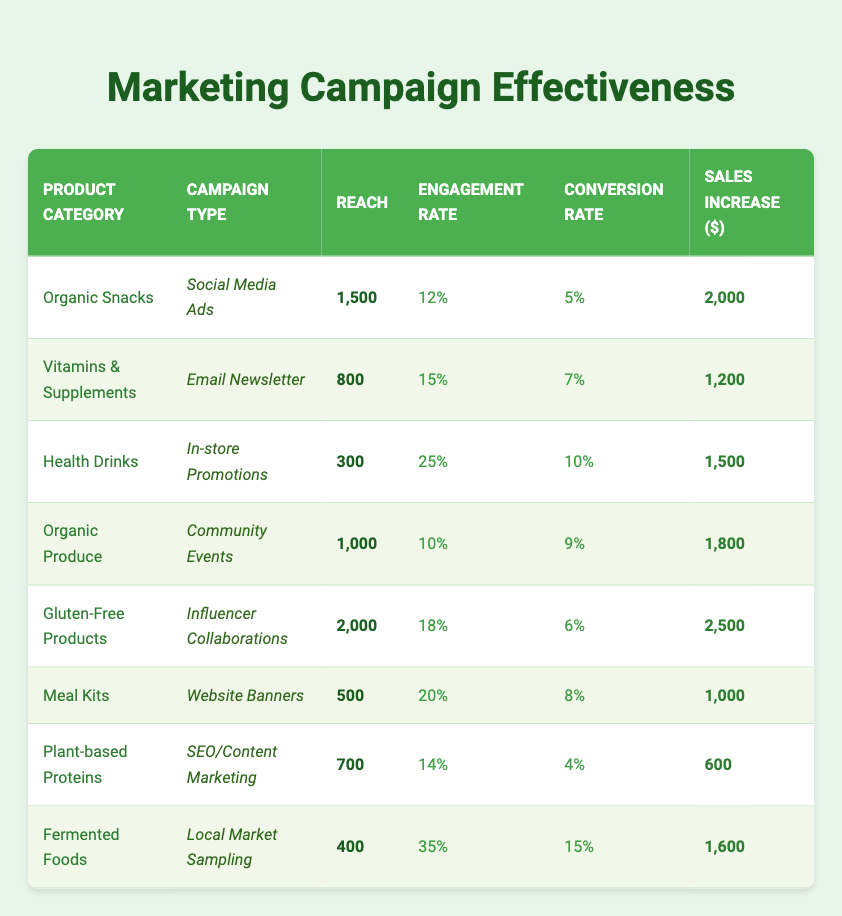What is the highest sales increase from a marketing campaign? The highest sales increase value in the table is found in the row for "Gluten-Free Products" with a sales increase of 2500.
Answer: 2500 Which product category was promoted through Social Media Ads? The product category that was promoted through Social Media Ads is "Organic Snacks".
Answer: Organic Snacks What is the total reach of all marketing campaigns listed? To find the total reach, we sum the reach values: 1500 + 800 + 300 + 1000 + 2000 + 500 + 700 + 400 = 6200.
Answer: 6200 Did the "Health Drinks" campaign have a higher engagement rate than "Organic Produce"? The engagement rate for "Health Drinks" is 25%, while for "Organic Produce" it is 10%. Thus, Health Drinks engaged more.
Answer: Yes What is the average conversion rate for all campaigns? To find the average conversion rate, sum the conversion rates: (0.05 + 0.07 + 0.1 + 0.09 + 0.06 + 0.08 + 0.04 + 0.15) = 0.64 then divide by the number of campaigns, which is 8. The average conversion rate is 0.64 / 8 = 0.08 or 8%.
Answer: 8% Which campaign type generated the highest engagement rate? By reviewing the engagement rates, "Fermented Foods" campaign with Local Market Sampling had the highest engagement rate of 35%.
Answer: 35% Is there a product category that has a conversion rate of 10% or more? Yes, both "Health Drinks" (10%) and "Fermented Foods" (15%) have conversion rates of 10% or higher.
Answer: Yes What is the sales increase of "Plant-based Proteins"? The sales increase for "Plant-based Proteins" is clearly stated in its row as 600.
Answer: 600 Which product category had the least reach among the campaigns? Among all the campaigns, "Health Drinks" had the least reach with just 300.
Answer: 300 